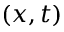<formula> <loc_0><loc_0><loc_500><loc_500>( x , t )</formula> 